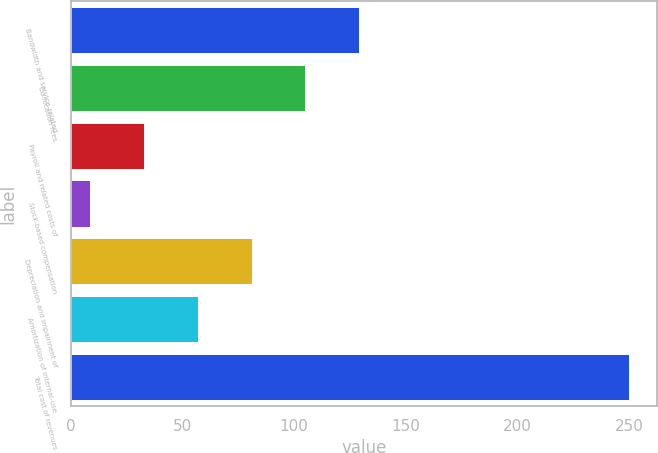<chart> <loc_0><loc_0><loc_500><loc_500><bar_chart><fcel>Bandwidth and service-related<fcel>Co-location fees<fcel>Payroll and related costs of<fcel>Stock-based compensation<fcel>Depreciation and impairment of<fcel>Amortization of internal-use<fcel>Total cost of revenues<nl><fcel>129.25<fcel>105.12<fcel>32.73<fcel>8.6<fcel>80.99<fcel>56.86<fcel>249.9<nl></chart> 